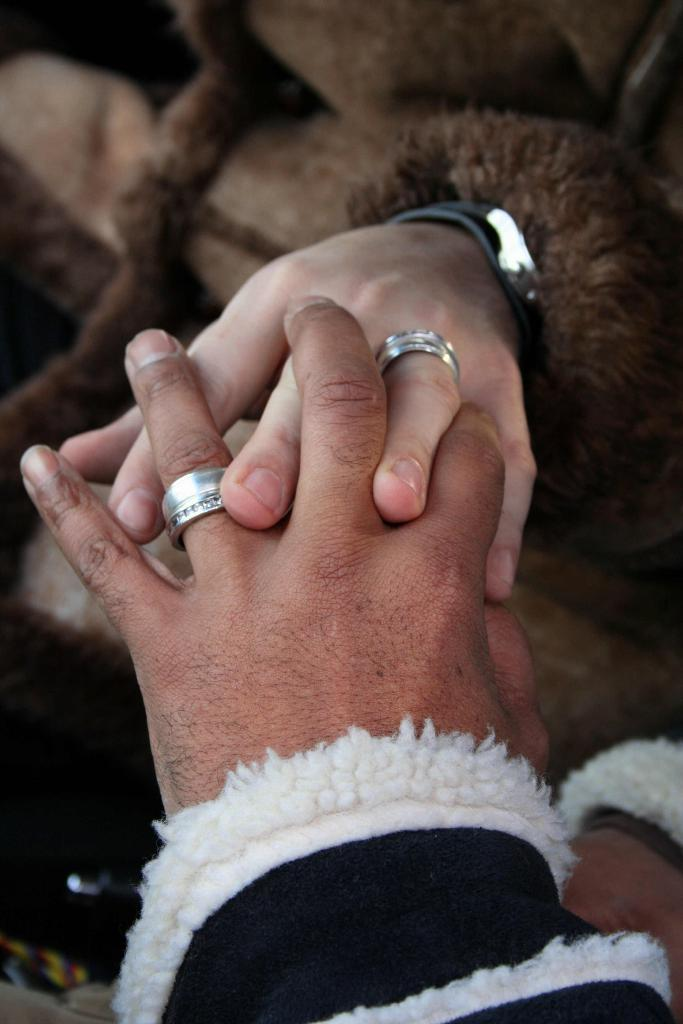How many people are in the image? There are two people in the image. What are the people doing in the image? The people are holding hands. What colors are the dresses worn by the people in the image? One person is wearing a white dress, one person is wearing a black dress, and one person is wearing a brown dress. What type of jewelry can be seen on the people's fingers in the image? There are silver rings on the fingers of the people. How many cats are visible in the image? There are no cats present in the image. 